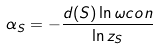<formula> <loc_0><loc_0><loc_500><loc_500>\alpha _ { S } = - \frac { d ( S ) \ln \omega c o n } { \ln z _ { S } }</formula> 